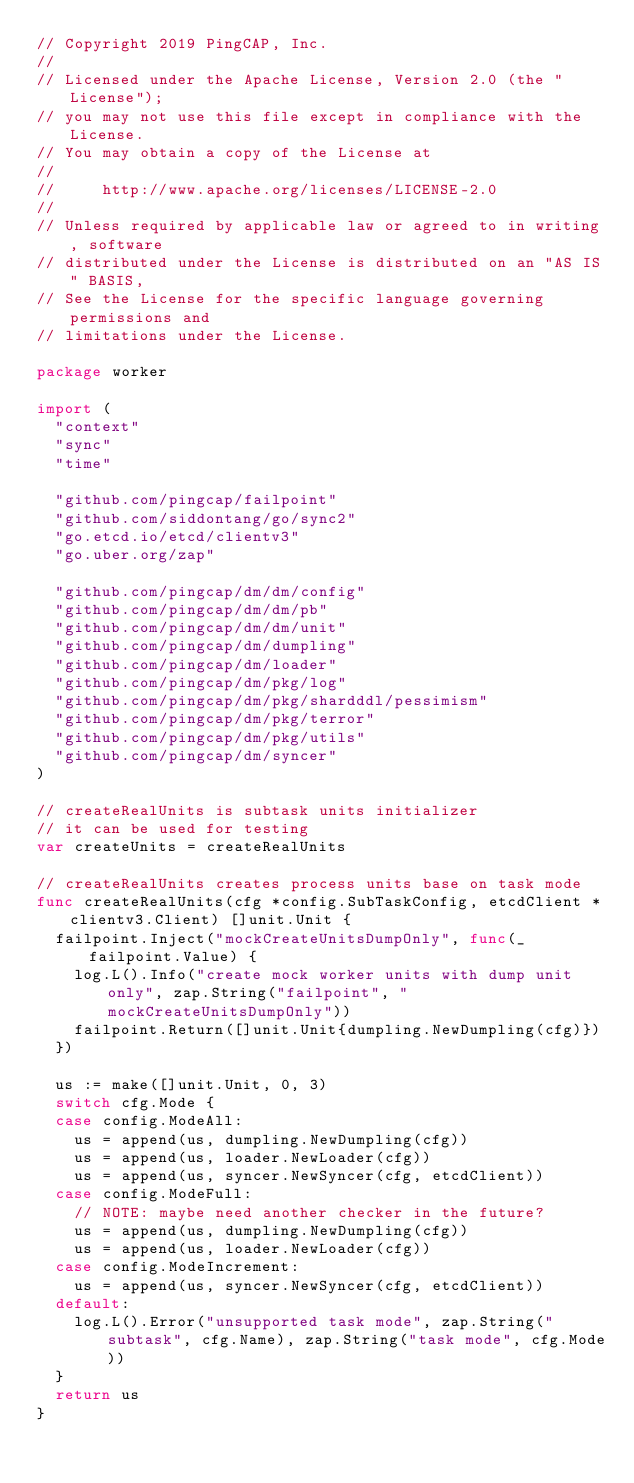<code> <loc_0><loc_0><loc_500><loc_500><_Go_>// Copyright 2019 PingCAP, Inc.
//
// Licensed under the Apache License, Version 2.0 (the "License");
// you may not use this file except in compliance with the License.
// You may obtain a copy of the License at
//
//     http://www.apache.org/licenses/LICENSE-2.0
//
// Unless required by applicable law or agreed to in writing, software
// distributed under the License is distributed on an "AS IS" BASIS,
// See the License for the specific language governing permissions and
// limitations under the License.

package worker

import (
	"context"
	"sync"
	"time"

	"github.com/pingcap/failpoint"
	"github.com/siddontang/go/sync2"
	"go.etcd.io/etcd/clientv3"
	"go.uber.org/zap"

	"github.com/pingcap/dm/dm/config"
	"github.com/pingcap/dm/dm/pb"
	"github.com/pingcap/dm/dm/unit"
	"github.com/pingcap/dm/dumpling"
	"github.com/pingcap/dm/loader"
	"github.com/pingcap/dm/pkg/log"
	"github.com/pingcap/dm/pkg/shardddl/pessimism"
	"github.com/pingcap/dm/pkg/terror"
	"github.com/pingcap/dm/pkg/utils"
	"github.com/pingcap/dm/syncer"
)

// createRealUnits is subtask units initializer
// it can be used for testing
var createUnits = createRealUnits

// createRealUnits creates process units base on task mode
func createRealUnits(cfg *config.SubTaskConfig, etcdClient *clientv3.Client) []unit.Unit {
	failpoint.Inject("mockCreateUnitsDumpOnly", func(_ failpoint.Value) {
		log.L().Info("create mock worker units with dump unit only", zap.String("failpoint", "mockCreateUnitsDumpOnly"))
		failpoint.Return([]unit.Unit{dumpling.NewDumpling(cfg)})
	})

	us := make([]unit.Unit, 0, 3)
	switch cfg.Mode {
	case config.ModeAll:
		us = append(us, dumpling.NewDumpling(cfg))
		us = append(us, loader.NewLoader(cfg))
		us = append(us, syncer.NewSyncer(cfg, etcdClient))
	case config.ModeFull:
		// NOTE: maybe need another checker in the future?
		us = append(us, dumpling.NewDumpling(cfg))
		us = append(us, loader.NewLoader(cfg))
	case config.ModeIncrement:
		us = append(us, syncer.NewSyncer(cfg, etcdClient))
	default:
		log.L().Error("unsupported task mode", zap.String("subtask", cfg.Name), zap.String("task mode", cfg.Mode))
	}
	return us
}
</code> 